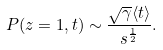Convert formula to latex. <formula><loc_0><loc_0><loc_500><loc_500>P ( z = 1 , t ) \sim \frac { \sqrt { \gamma } \langle t \rangle } { s ^ { \frac { 1 } { 2 } } } .</formula> 